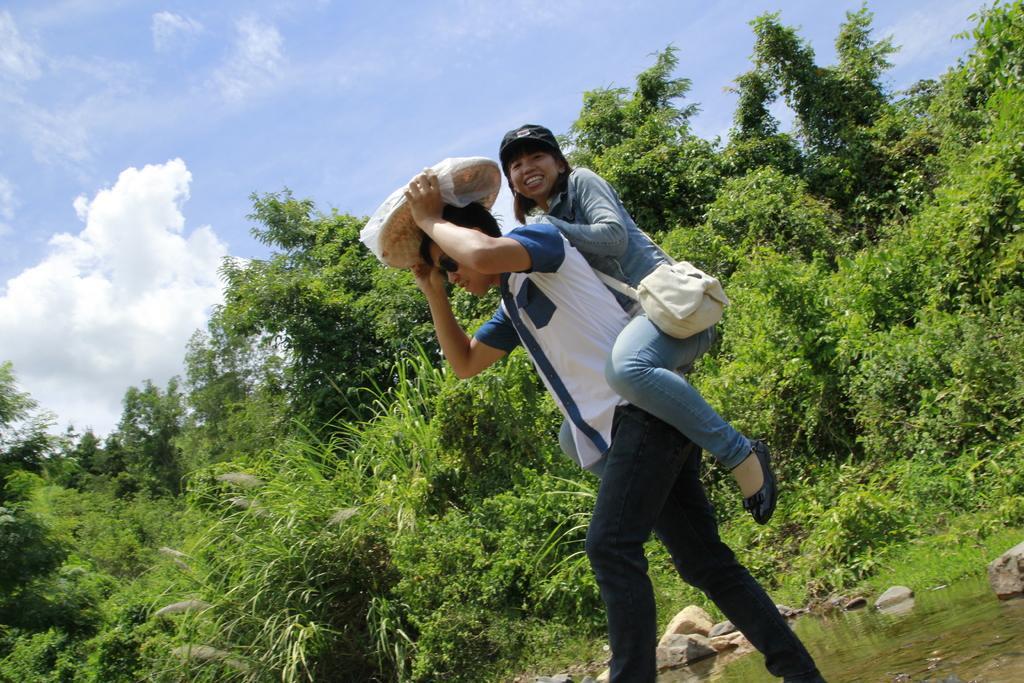How would you summarize this image in a sentence or two? In this picture there is a man who is wearing goggle, t-shirt, bag and jeans. He is holding a plastic cover. Back side of him we can see woman who is wearing shirt, black jeans and shoe. He is walking on the water. In the background we can see many trees, plants and glass. Here we can see stones near to the water. On the top we can see sky and clouds. 